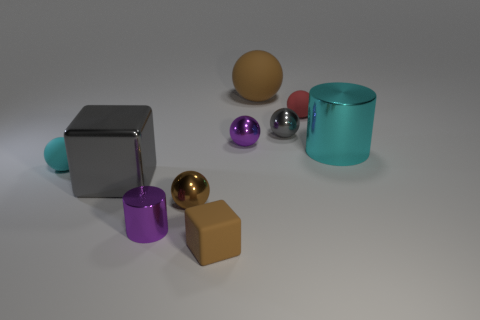There is a rubber thing that is the same color as the large shiny cylinder; what is its shape?
Your answer should be compact. Sphere. There is a big rubber ball; is its color the same as the tiny metallic sphere that is in front of the large cyan thing?
Offer a terse response. Yes. Are there any tiny matte things that have the same color as the large ball?
Your answer should be compact. Yes. The rubber sphere that is the same color as the tiny cube is what size?
Offer a terse response. Large. What number of other things are there of the same shape as the red rubber object?
Your response must be concise. 5. How many objects are purple metallic cylinders or tiny matte objects?
Give a very brief answer. 4. Do the matte cube and the large matte ball have the same color?
Provide a succinct answer. Yes. There is a purple metal object that is right of the brown sphere that is in front of the red matte thing; what shape is it?
Keep it short and to the point. Sphere. Are there fewer tiny things than cyan cylinders?
Your answer should be compact. No. What size is the matte object that is both to the right of the small cyan matte ball and in front of the small gray metallic ball?
Ensure brevity in your answer.  Small. 